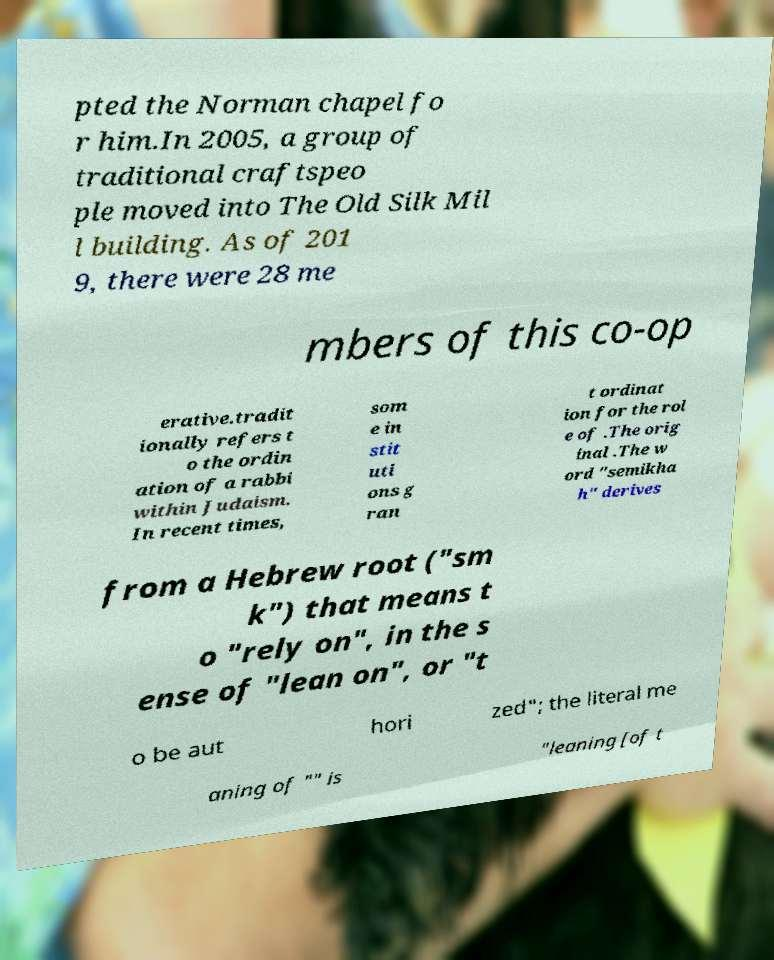What messages or text are displayed in this image? I need them in a readable, typed format. pted the Norman chapel fo r him.In 2005, a group of traditional craftspeo ple moved into The Old Silk Mil l building. As of 201 9, there were 28 me mbers of this co-op erative.tradit ionally refers t o the ordin ation of a rabbi within Judaism. In recent times, som e in stit uti ons g ran t ordinat ion for the rol e of .The orig inal .The w ord "semikha h" derives from a Hebrew root ("sm k") that means t o "rely on", in the s ense of "lean on", or "t o be aut hori zed"; the literal me aning of "" is "leaning [of t 